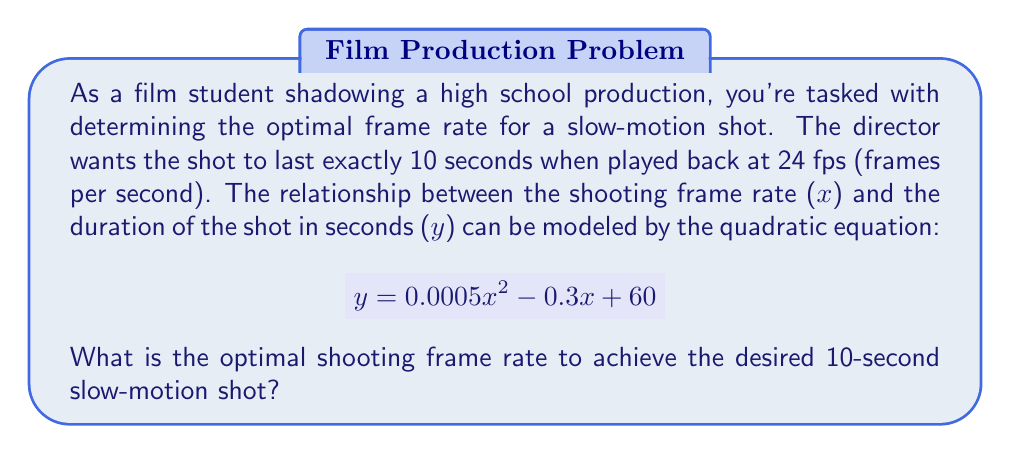Help me with this question. To solve this problem, we need to follow these steps:

1) We know that the playback duration should be 10 seconds, so we set $y = 10$ in our equation:

   $$ 10 = 0.0005x^2 - 0.3x + 60 $$

2) Rearrange the equation to standard form:

   $$ 0.0005x^2 - 0.3x + 50 = 0 $$

3) This is a quadratic equation in the form $ax^2 + bx + c = 0$, where:
   $a = 0.0005$
   $b = -0.3$
   $c = 50$

4) We can solve this using the quadratic formula: $x = \frac{-b \pm \sqrt{b^2 - 4ac}}{2a}$

5) Substituting our values:

   $$ x = \frac{0.3 \pm \sqrt{(-0.3)^2 - 4(0.0005)(50)}}{2(0.0005)} $$

6) Simplify:

   $$ x = \frac{0.3 \pm \sqrt{0.09 - 0.1}}{0.001} = \frac{0.3 \pm \sqrt{-0.01}}{0.001} $$

7) The negative value under the square root indicates that there are no real solutions. This means our quadratic model doesn't intersect with $y = 10$ at any point.

8) In practical terms, this suggests that we need to adjust our approach. Since we're dealing with frame rates, we should consider only positive values. The optimal frame rate would be the one that gets us closest to 10 seconds.

9) We can find this by graphing the function and looking for the minimum point. The vertex of the parabola will give us this information.

10) The x-coordinate of the vertex is given by $x = -\frac{b}{2a}$:

    $$ x = -\frac{-0.3}{2(0.0005)} = 300 $$

11) This means that 300 fps is the frame rate that will give us the slowest playback time.
Answer: The optimal shooting frame rate is 300 fps. 